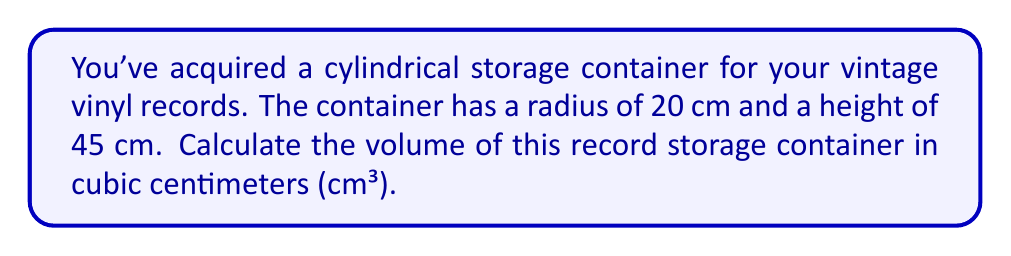What is the answer to this math problem? To compute the volume of a cylindrical container, we use the formula for the volume of a cylinder:

$$V = \pi r^2 h$$

Where:
$V$ = volume
$\pi$ = pi (approximately 3.14159)
$r$ = radius of the base
$h$ = height of the cylinder

Given:
$r = 20$ cm
$h = 45$ cm

Let's substitute these values into the formula:

$$\begin{align*}
V &= \pi r^2 h \\
&= \pi \cdot (20\text{ cm})^2 \cdot 45\text{ cm} \\
&= \pi \cdot 400\text{ cm}^2 \cdot 45\text{ cm} \\
&= 18000\pi\text{ cm}^3
\end{align*}$$

Using $\pi \approx 3.14159$, we can calculate the approximate volume:

$$V \approx 18000 \cdot 3.14159\text{ cm}^3 \approx 56548.62\text{ cm}^3$$

Rounding to the nearest whole number:

$$V \approx 56549\text{ cm}^3$$

[asy]
import geometry;

size(200);
real r = 20;
real h = 45;
pair O = (0,0);

draw(circle(O, r));
draw((r,0)--(r,h)--(-r,h)--(-r,0));
draw((-r,h)--(r,h), dashed);
draw((0,0)--(r,0), Arrow);
draw((r,0)--(r,h), Arrow);

label("r", (r/2,0), S);
label("h", (r,h/2), E);

[/asy]
Answer: The volume of the cylindrical record storage container is approximately 56549 cm³. 